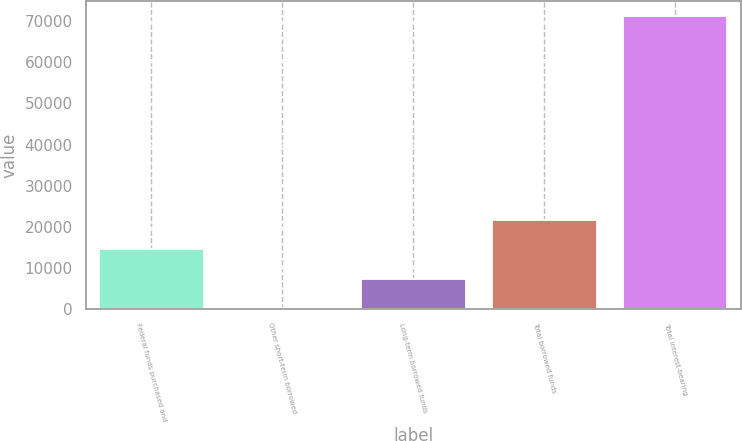Convert chart to OTSL. <chart><loc_0><loc_0><loc_500><loc_500><bar_chart><fcel>Federal funds purchased and<fcel>Other short-term borrowed<fcel>Long-term borrowed funds<fcel>Total borrowed funds<fcel>Total interest-bearing<nl><fcel>14474<fcel>251<fcel>7362.5<fcel>21585.5<fcel>71366<nl></chart> 